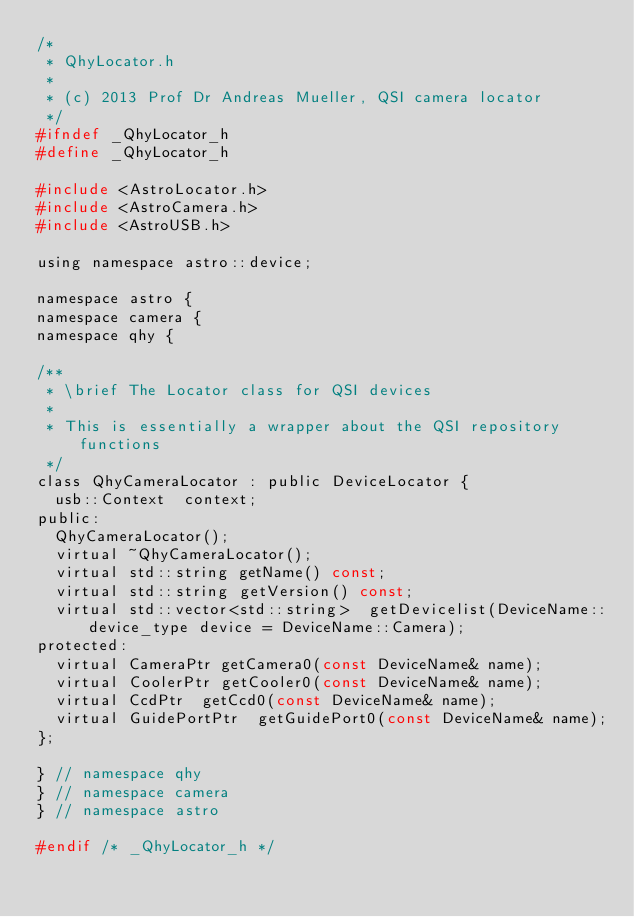<code> <loc_0><loc_0><loc_500><loc_500><_C_>/*
 * QhyLocator.h
 *
 * (c) 2013 Prof Dr Andreas Mueller, QSI camera locator
 */
#ifndef _QhyLocator_h
#define _QhyLocator_h

#include <AstroLocator.h>
#include <AstroCamera.h>
#include <AstroUSB.h>

using namespace astro::device;

namespace astro {
namespace camera {
namespace qhy {

/**
 * \brief The Locator class for QSI devices
 *
 * This is essentially a wrapper about the QSI repository functions
 */
class QhyCameraLocator : public DeviceLocator {
	usb::Context	context;
public:
	QhyCameraLocator();
	virtual ~QhyCameraLocator();
	virtual std::string	getName() const;
	virtual std::string	getVersion() const;
	virtual std::vector<std::string>	getDevicelist(DeviceName::device_type device = DeviceName::Camera);
protected:
	virtual CameraPtr	getCamera0(const DeviceName& name);
	virtual CoolerPtr	getCooler0(const DeviceName& name);
	virtual CcdPtr	getCcd0(const DeviceName& name);
	virtual GuidePortPtr	getGuidePort0(const DeviceName& name);
};

} // namespace qhy
} // namespace camera
} // namespace astro

#endif /* _QhyLocator_h */
</code> 